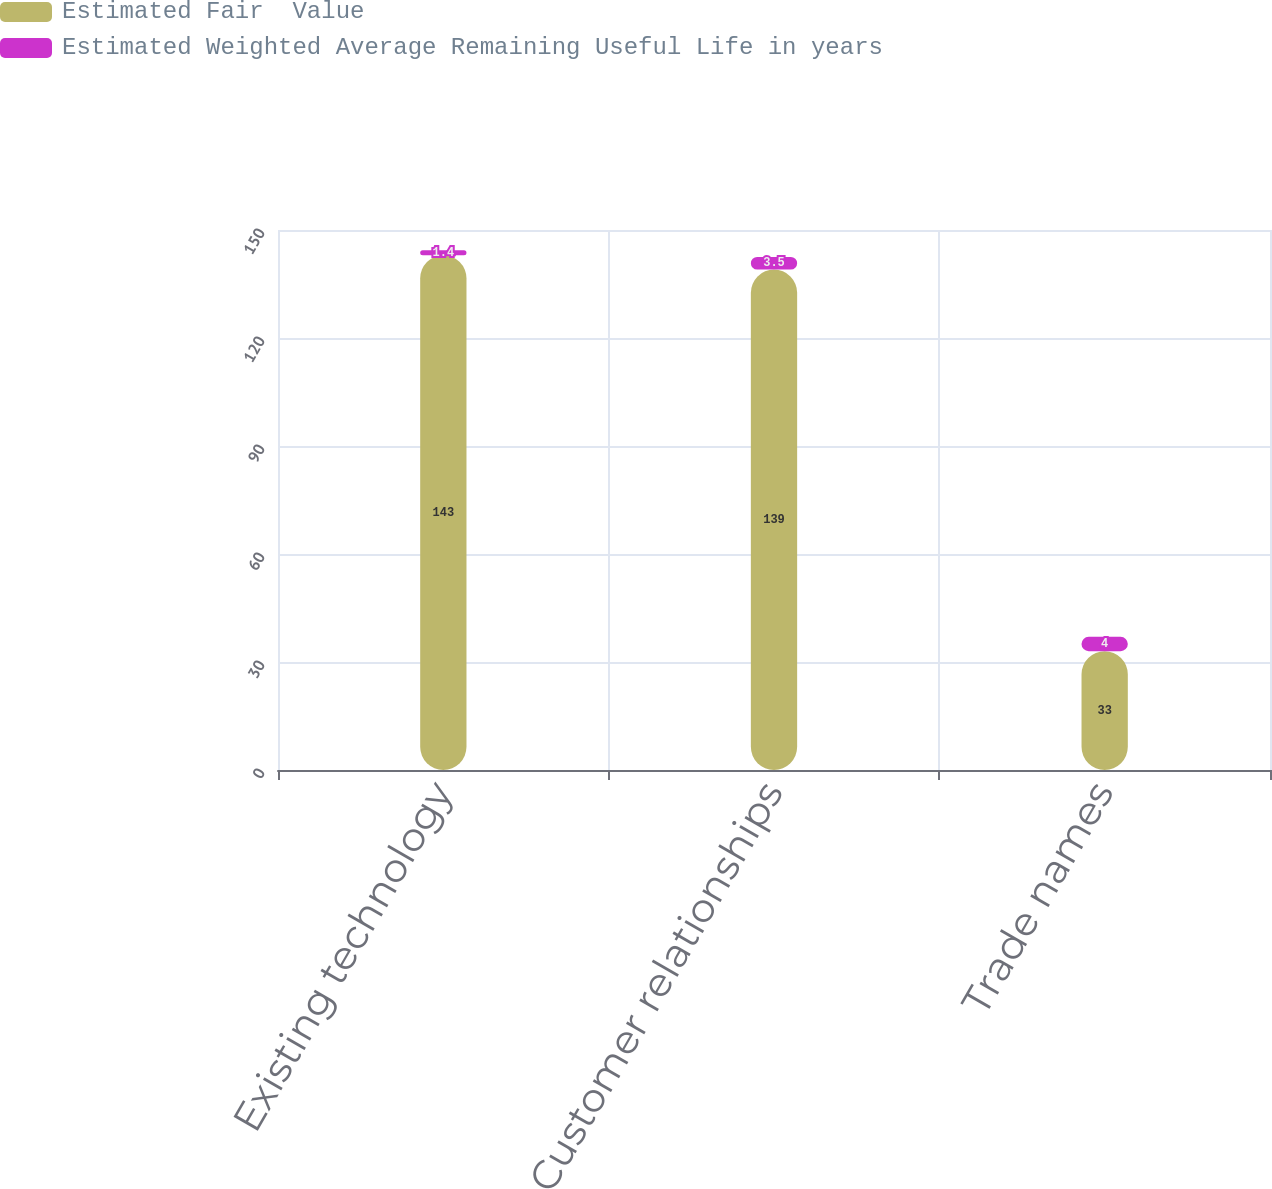Convert chart. <chart><loc_0><loc_0><loc_500><loc_500><stacked_bar_chart><ecel><fcel>Existing technology<fcel>Customer relationships<fcel>Trade names<nl><fcel>Estimated Fair  Value<fcel>143<fcel>139<fcel>33<nl><fcel>Estimated Weighted Average Remaining Useful Life in years<fcel>1.4<fcel>3.5<fcel>4<nl></chart> 